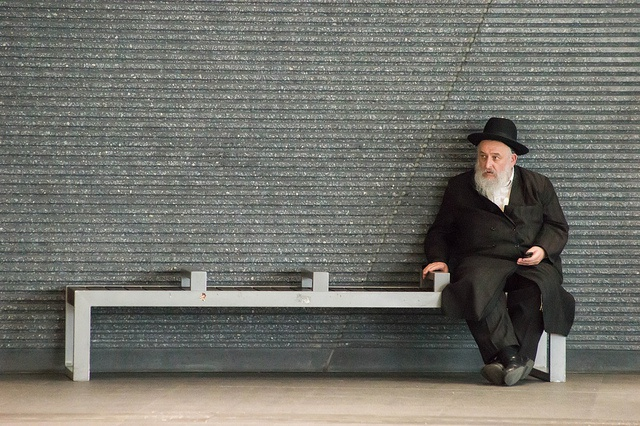Describe the objects in this image and their specific colors. I can see people in darkgreen, black, gray, and tan tones and bench in darkgreen, lightgray, darkgray, and black tones in this image. 